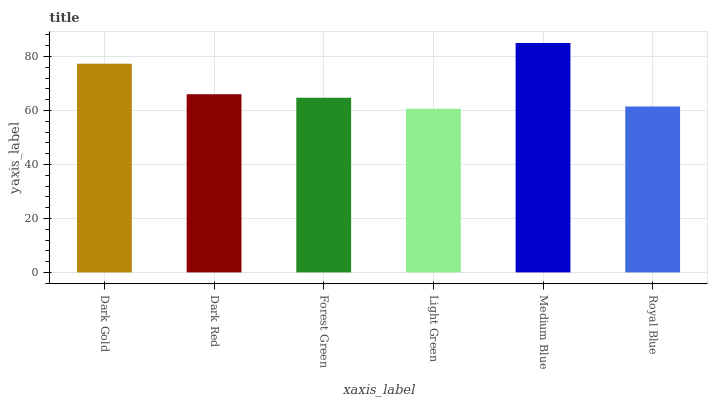Is Light Green the minimum?
Answer yes or no. Yes. Is Medium Blue the maximum?
Answer yes or no. Yes. Is Dark Red the minimum?
Answer yes or no. No. Is Dark Red the maximum?
Answer yes or no. No. Is Dark Gold greater than Dark Red?
Answer yes or no. Yes. Is Dark Red less than Dark Gold?
Answer yes or no. Yes. Is Dark Red greater than Dark Gold?
Answer yes or no. No. Is Dark Gold less than Dark Red?
Answer yes or no. No. Is Dark Red the high median?
Answer yes or no. Yes. Is Forest Green the low median?
Answer yes or no. Yes. Is Dark Gold the high median?
Answer yes or no. No. Is Dark Red the low median?
Answer yes or no. No. 